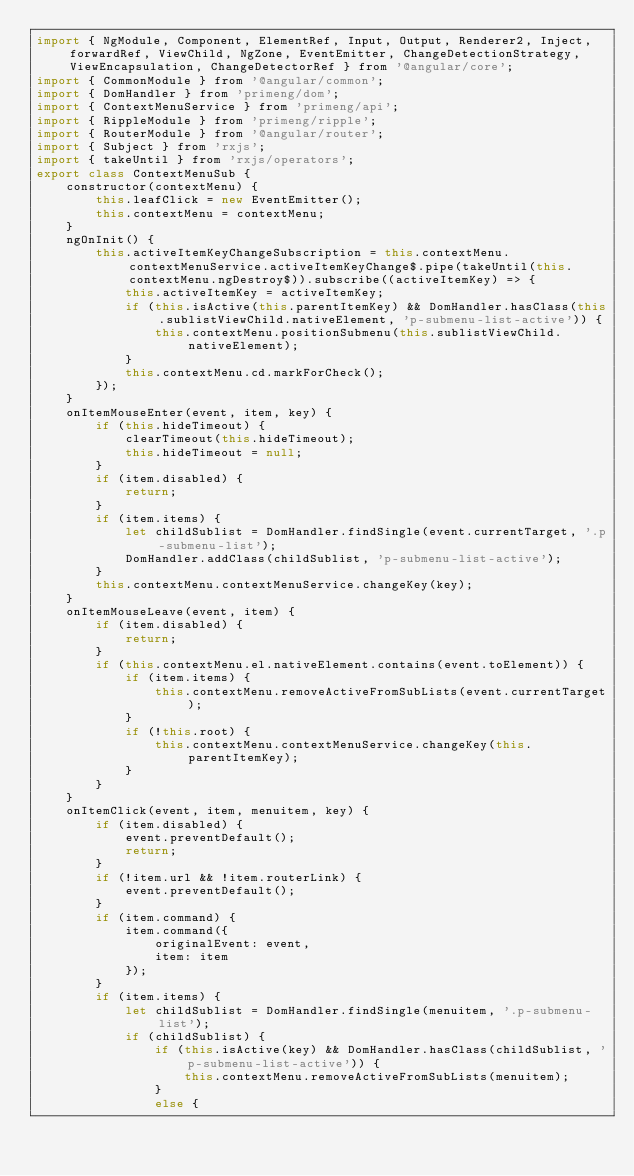Convert code to text. <code><loc_0><loc_0><loc_500><loc_500><_JavaScript_>import { NgModule, Component, ElementRef, Input, Output, Renderer2, Inject, forwardRef, ViewChild, NgZone, EventEmitter, ChangeDetectionStrategy, ViewEncapsulation, ChangeDetectorRef } from '@angular/core';
import { CommonModule } from '@angular/common';
import { DomHandler } from 'primeng/dom';
import { ContextMenuService } from 'primeng/api';
import { RippleModule } from 'primeng/ripple';
import { RouterModule } from '@angular/router';
import { Subject } from 'rxjs';
import { takeUntil } from 'rxjs/operators';
export class ContextMenuSub {
    constructor(contextMenu) {
        this.leafClick = new EventEmitter();
        this.contextMenu = contextMenu;
    }
    ngOnInit() {
        this.activeItemKeyChangeSubscription = this.contextMenu.contextMenuService.activeItemKeyChange$.pipe(takeUntil(this.contextMenu.ngDestroy$)).subscribe((activeItemKey) => {
            this.activeItemKey = activeItemKey;
            if (this.isActive(this.parentItemKey) && DomHandler.hasClass(this.sublistViewChild.nativeElement, 'p-submenu-list-active')) {
                this.contextMenu.positionSubmenu(this.sublistViewChild.nativeElement);
            }
            this.contextMenu.cd.markForCheck();
        });
    }
    onItemMouseEnter(event, item, key) {
        if (this.hideTimeout) {
            clearTimeout(this.hideTimeout);
            this.hideTimeout = null;
        }
        if (item.disabled) {
            return;
        }
        if (item.items) {
            let childSublist = DomHandler.findSingle(event.currentTarget, '.p-submenu-list');
            DomHandler.addClass(childSublist, 'p-submenu-list-active');
        }
        this.contextMenu.contextMenuService.changeKey(key);
    }
    onItemMouseLeave(event, item) {
        if (item.disabled) {
            return;
        }
        if (this.contextMenu.el.nativeElement.contains(event.toElement)) {
            if (item.items) {
                this.contextMenu.removeActiveFromSubLists(event.currentTarget);
            }
            if (!this.root) {
                this.contextMenu.contextMenuService.changeKey(this.parentItemKey);
            }
        }
    }
    onItemClick(event, item, menuitem, key) {
        if (item.disabled) {
            event.preventDefault();
            return;
        }
        if (!item.url && !item.routerLink) {
            event.preventDefault();
        }
        if (item.command) {
            item.command({
                originalEvent: event,
                item: item
            });
        }
        if (item.items) {
            let childSublist = DomHandler.findSingle(menuitem, '.p-submenu-list');
            if (childSublist) {
                if (this.isActive(key) && DomHandler.hasClass(childSublist, 'p-submenu-list-active')) {
                    this.contextMenu.removeActiveFromSubLists(menuitem);
                }
                else {</code> 